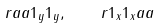Convert formula to latex. <formula><loc_0><loc_0><loc_500><loc_500>r { a } { a } { 1 _ { y } } { 1 _ { y } } , \quad r { 1 _ { x } } { 1 _ { x } } { a } { a }</formula> 